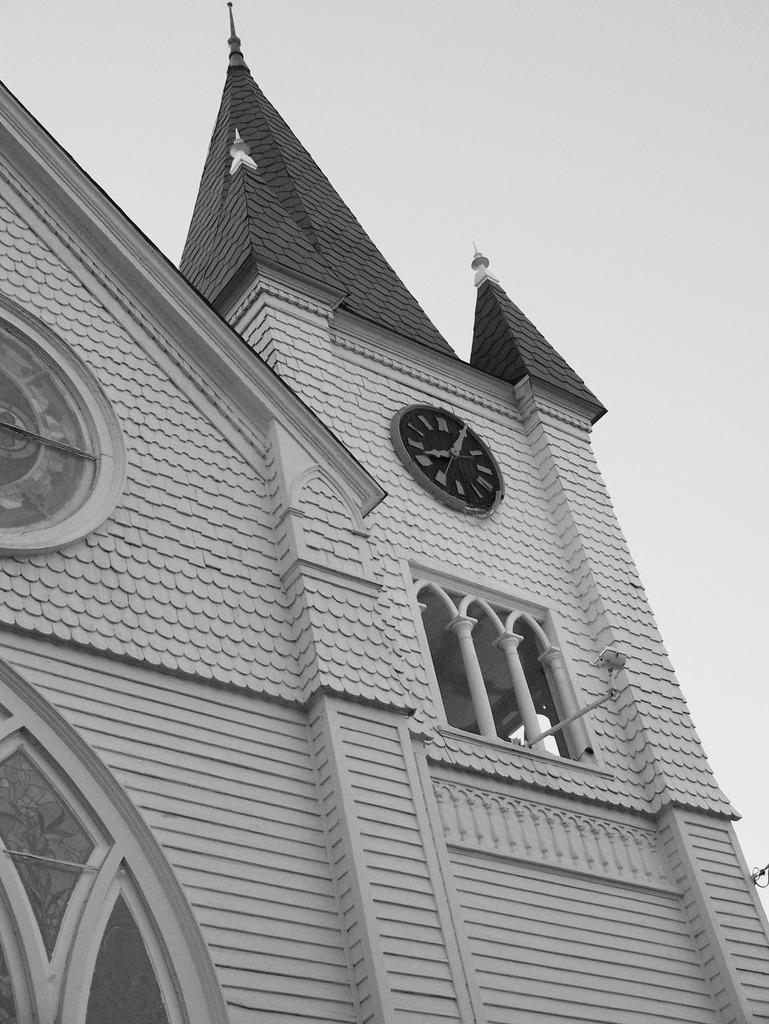What type of structure is present in the image? There is a building in the image. What feature can be seen on the building? There is a clock on the building. What can be seen in the background of the image? The sky is visible in the background of the image. How is the image presented in terms of color? The image is black and white. What type of religious symbol can be seen on the building in the image? There is no religious symbol present on the building in the image. Can you tell me how the people in the image are expressing anger? There are no people present in the image, so it is not possible to determine their emotions. 